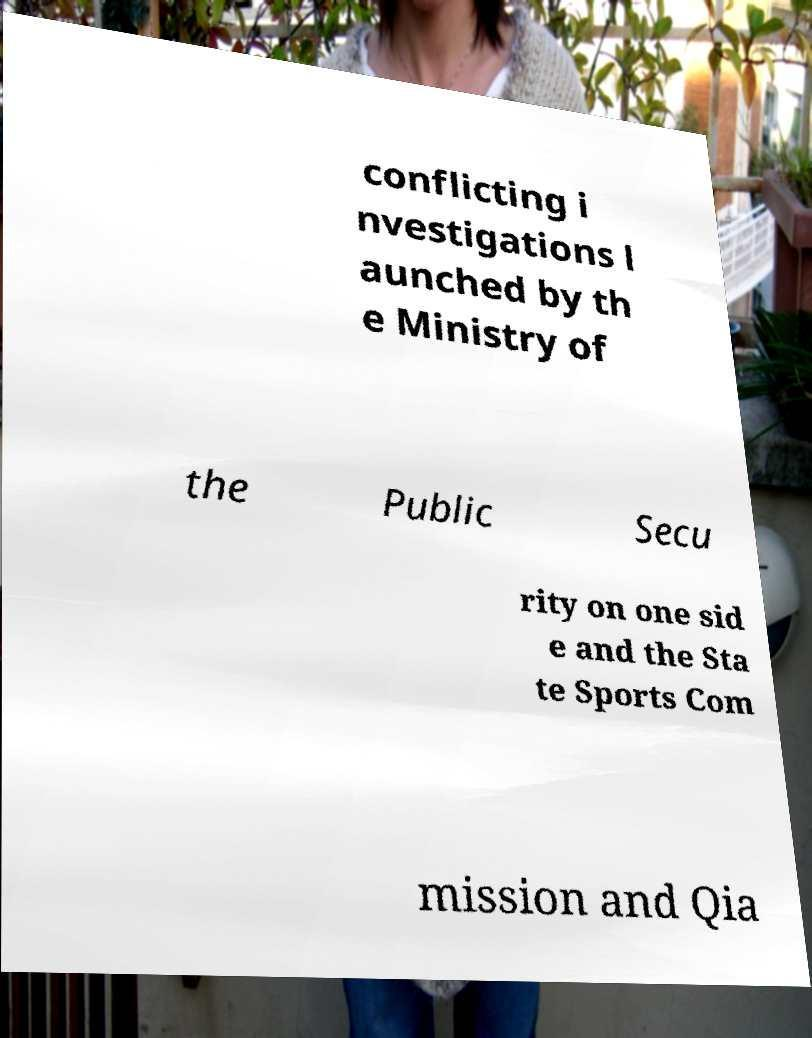I need the written content from this picture converted into text. Can you do that? conflicting i nvestigations l aunched by th e Ministry of the Public Secu rity on one sid e and the Sta te Sports Com mission and Qia 